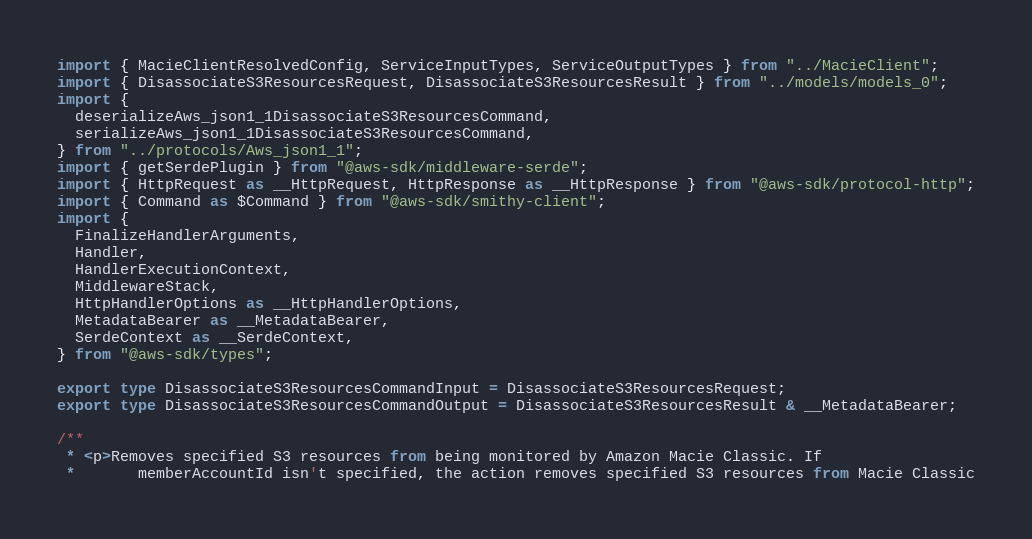Convert code to text. <code><loc_0><loc_0><loc_500><loc_500><_TypeScript_>import { MacieClientResolvedConfig, ServiceInputTypes, ServiceOutputTypes } from "../MacieClient";
import { DisassociateS3ResourcesRequest, DisassociateS3ResourcesResult } from "../models/models_0";
import {
  deserializeAws_json1_1DisassociateS3ResourcesCommand,
  serializeAws_json1_1DisassociateS3ResourcesCommand,
} from "../protocols/Aws_json1_1";
import { getSerdePlugin } from "@aws-sdk/middleware-serde";
import { HttpRequest as __HttpRequest, HttpResponse as __HttpResponse } from "@aws-sdk/protocol-http";
import { Command as $Command } from "@aws-sdk/smithy-client";
import {
  FinalizeHandlerArguments,
  Handler,
  HandlerExecutionContext,
  MiddlewareStack,
  HttpHandlerOptions as __HttpHandlerOptions,
  MetadataBearer as __MetadataBearer,
  SerdeContext as __SerdeContext,
} from "@aws-sdk/types";

export type DisassociateS3ResourcesCommandInput = DisassociateS3ResourcesRequest;
export type DisassociateS3ResourcesCommandOutput = DisassociateS3ResourcesResult & __MetadataBearer;

/**
 * <p>Removes specified S3 resources from being monitored by Amazon Macie Classic. If
 *       memberAccountId isn't specified, the action removes specified S3 resources from Macie Classic</code> 